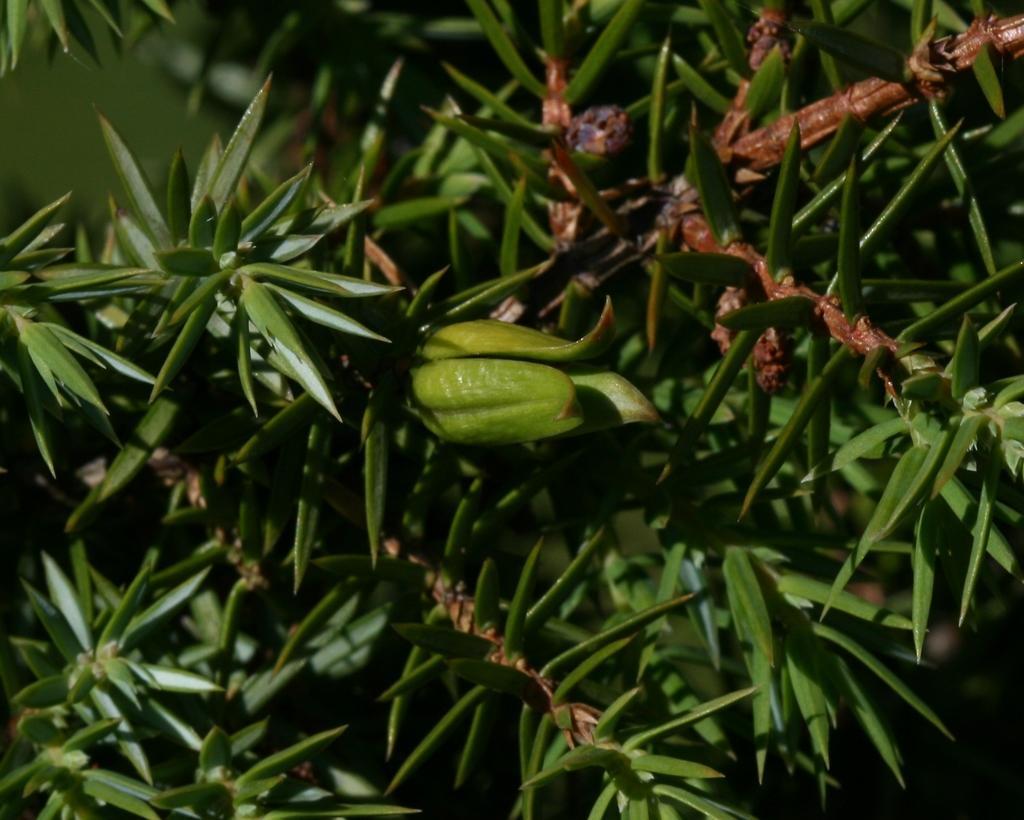In one or two sentences, can you explain what this image depicts? In this picture we can see a green plant with green leaves and brown stems. 